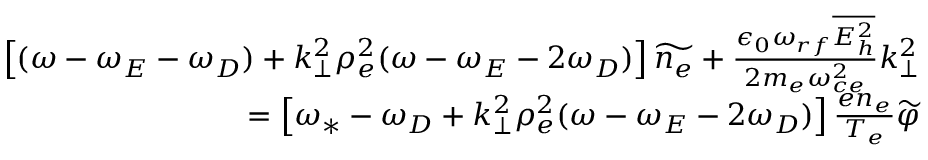<formula> <loc_0><loc_0><loc_500><loc_500>\begin{array} { r } { \left [ ( \omega - \omega _ { E } - \omega _ { D } ) + k _ { \perp } ^ { 2 } \rho _ { e } ^ { 2 } ( \omega - \omega _ { E } - 2 \omega _ { D } ) \right ] \widetilde { n _ { e } } + \frac { \epsilon _ { 0 } \omega _ { r f } \overline { { E _ { h } ^ { 2 } } } } { 2 m _ { e } \omega _ { c e } ^ { 2 } } k _ { \perp } ^ { 2 } } \\ { = \left [ \omega _ { * } - \omega _ { D } + k _ { \perp } ^ { 2 } \rho _ { e } ^ { 2 } ( \omega - \omega _ { E } - 2 \omega _ { D } ) \right ] \frac { e n _ { e } } { T _ { e } } \widetilde { \varphi } } \end{array}</formula> 